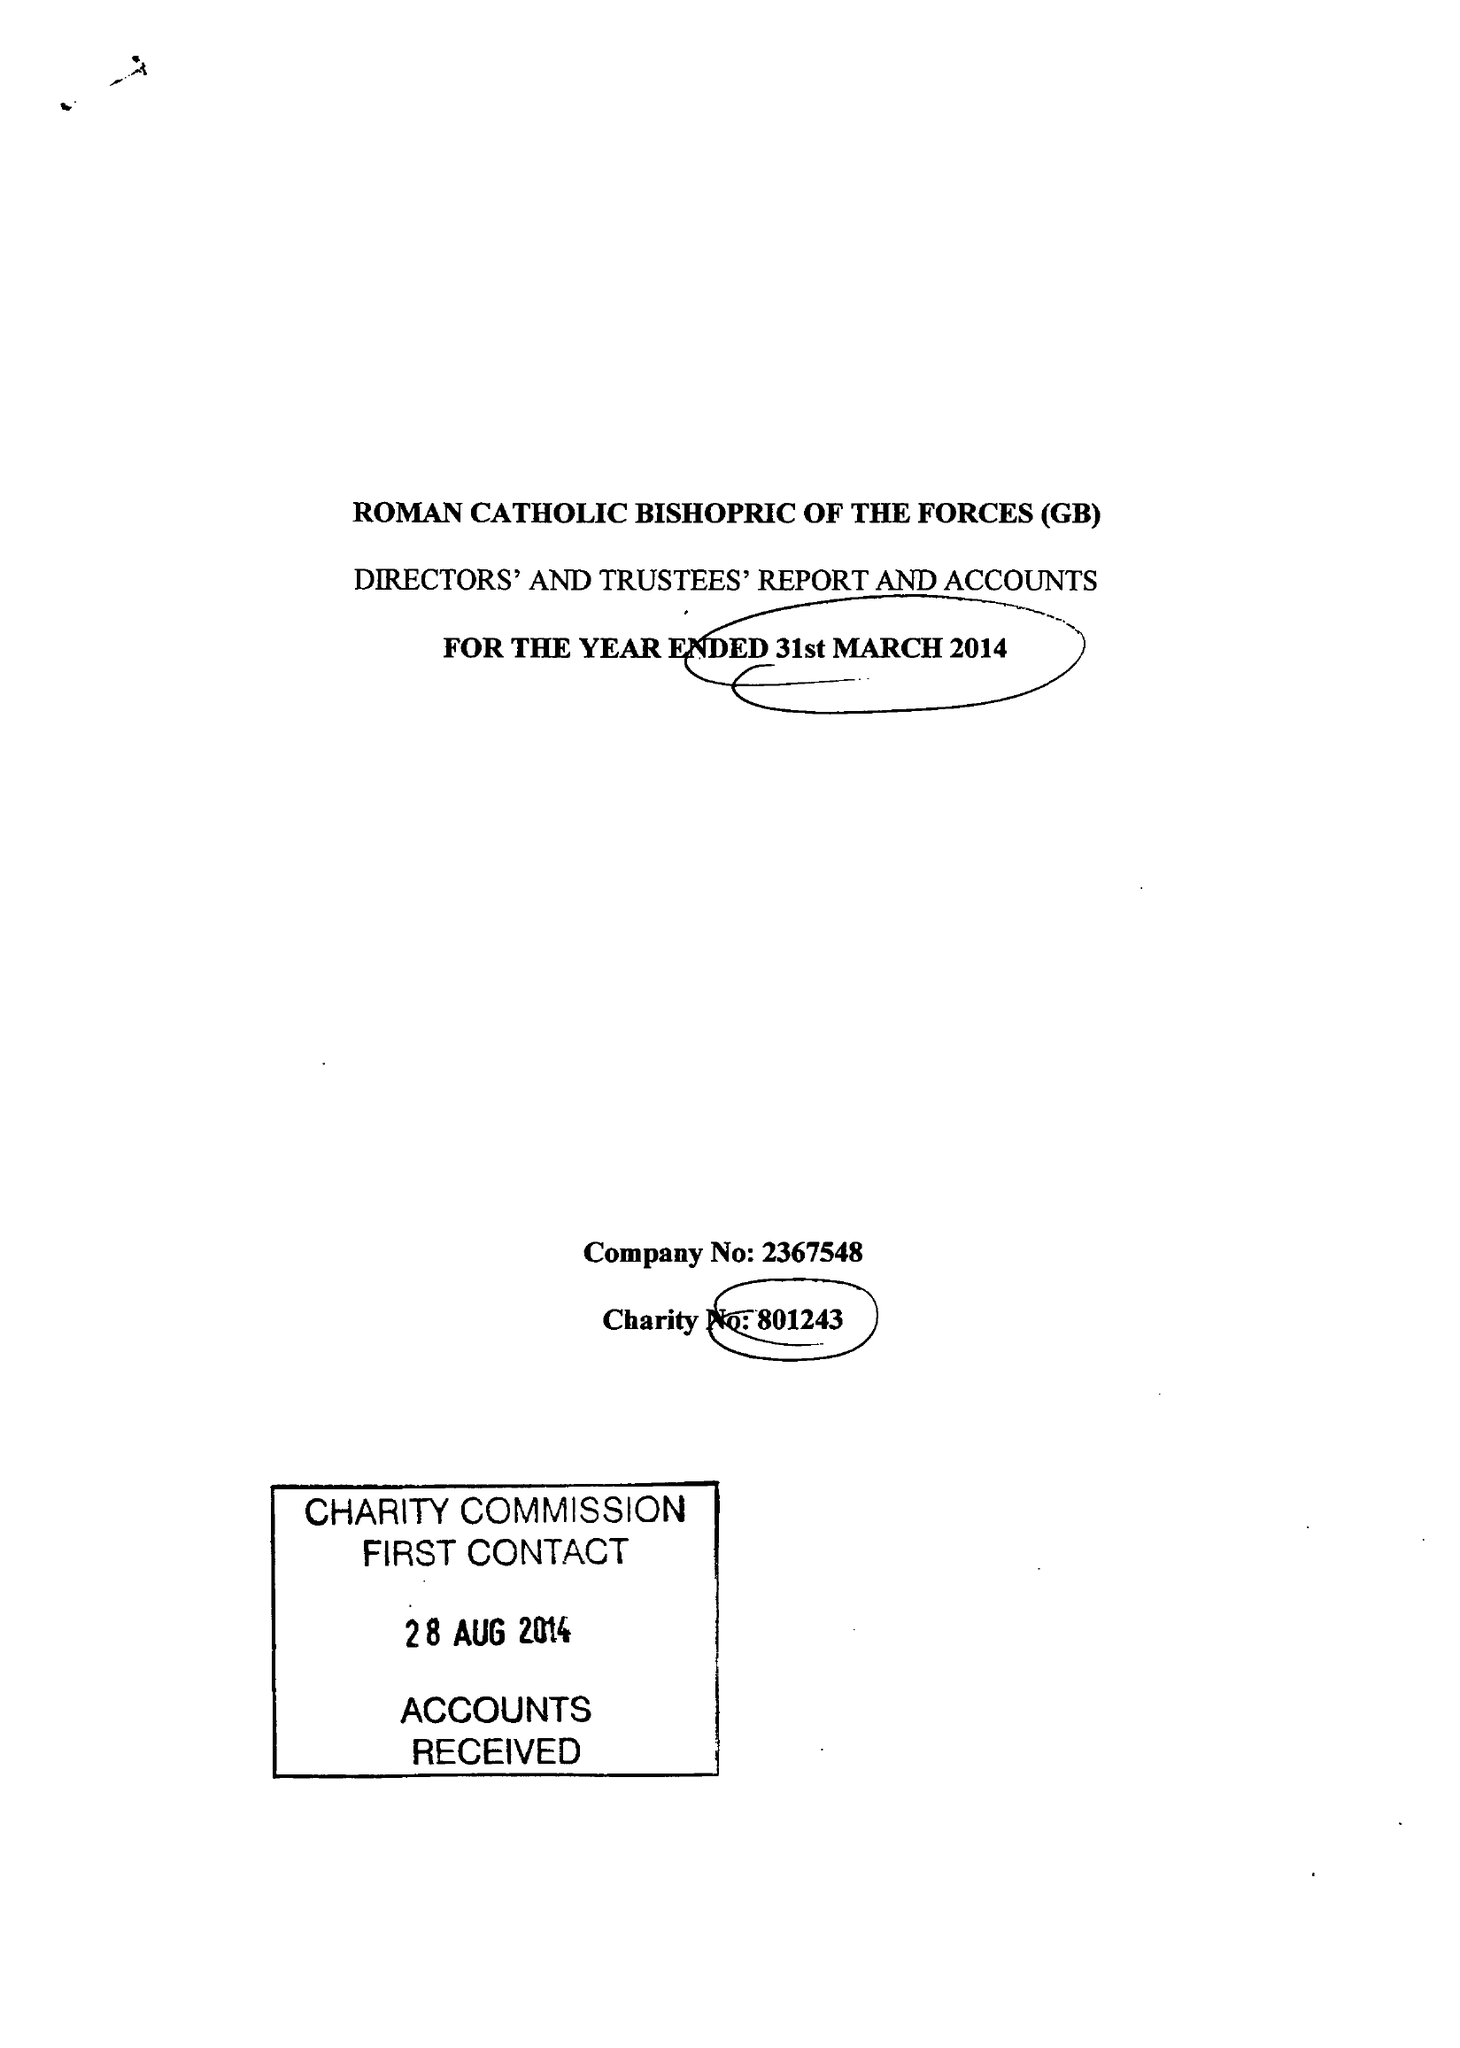What is the value for the spending_annually_in_british_pounds?
Answer the question using a single word or phrase. 120904.00 